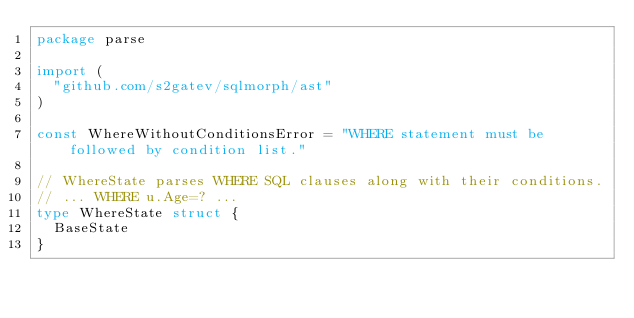Convert code to text. <code><loc_0><loc_0><loc_500><loc_500><_Go_>package parse

import (
	"github.com/s2gatev/sqlmorph/ast"
)

const WhereWithoutConditionsError = "WHERE statement must be followed by condition list."

// WhereState parses WHERE SQL clauses along with their conditions.
// ... WHERE u.Age=? ...
type WhereState struct {
	BaseState
}
</code> 